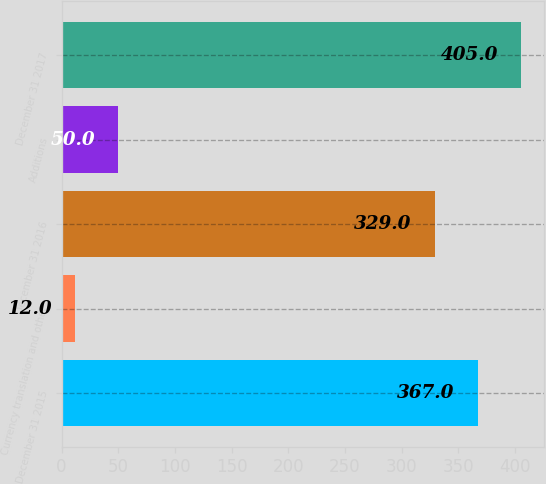<chart> <loc_0><loc_0><loc_500><loc_500><bar_chart><fcel>December 31 2015<fcel>Currency translation and other<fcel>December 31 2016<fcel>Additions<fcel>December 31 2017<nl><fcel>367<fcel>12<fcel>329<fcel>50<fcel>405<nl></chart> 